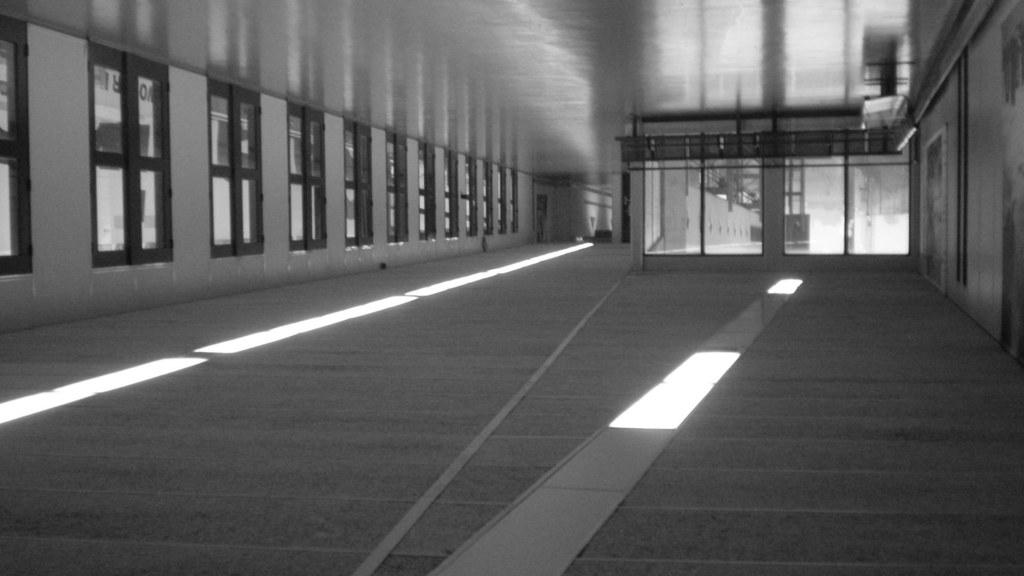What can be seen on the walls in the image? There are windows in the image. What is visible through the windows? There are objects visible behind the windows. What type of lighting is present on the floor in the image? There are lights on the floor in the image. What type of mint can be seen growing near the lights on the floor? There is no mint present in the image; the focus is on the windows and lights on the floor. 